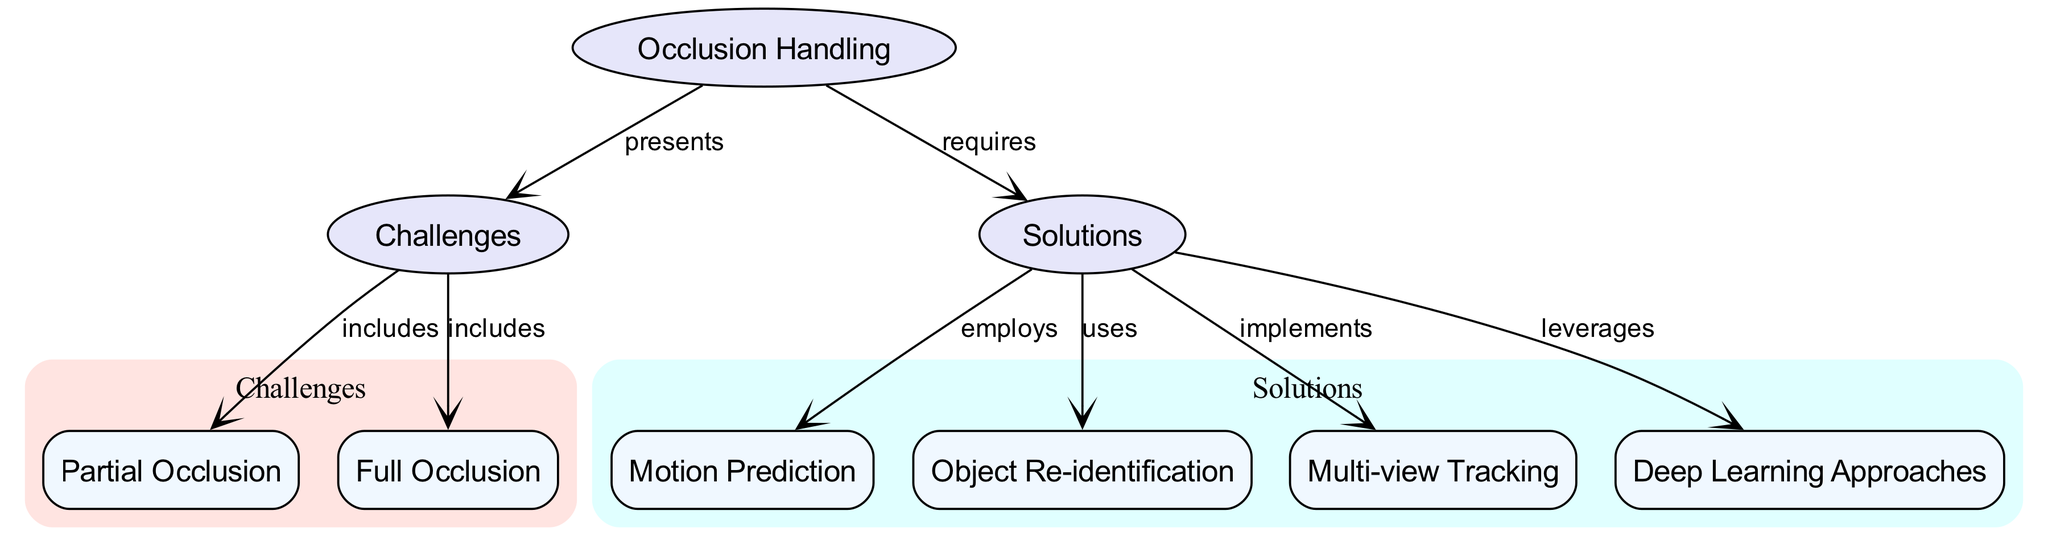What is the main topic of the concept map? The main topic is indicated by the central node "Occlusion Handling." It is the primary focus of the concept map as it serves as a parent node from which challenges and solutions branch out.
Answer: Occlusion Handling How many nodes are present in the concept map? By counting each unique entry in the nodes section of the data, we find there are eight nodes total connecting various concepts.
Answer: 8 What type of occlusion is included as a challenge in the diagram? The diagram indicates that both "Partial Occlusion" and "Full Occlusion" are included under the challenges node, showing two specific types recognized in motion tracking.
Answer: Partial Occlusion, Full Occlusion Which solution employs motion prediction? The diagram indicates that "Motion Prediction" is a solution that is employed under the solutions node, which is designed to address challenges related to occlusions.
Answer: Motion Prediction What connection is made between challenges and solutions? The diagram shows a clear relationship in that the node "Occlusion Handling" requires solutions to address the identified challenges, indicating a direct need for problem-solving approaches.
Answer: requires Which solution is associated with deep learning approaches? According to the diagram, there is a direct connection that states "Deep Learning Approaches" leverages one of the solutions provided to cope with challenges in occlusion handling.
Answer: Deep Learning Approaches How many specific solutions are listed in the diagram? The solutions node branches out into four distinct concepts, indicating multiple approaches to handle the challenges of occlusion, reflecting an array of solutions.
Answer: 4 Which type of tracking does the diagram indicate is implemented as a solution? The concept map highlights "Multi-view Tracking" specifically as one of the solutions used to enhance motion tracking's robustness against occlusions.
Answer: Multi-view Tracking What are the two types of challenges represented under challenges? The concept map lists the two types of occlusion challenges directly under the challenges node: "Partial Occlusion" and "Full Occlusion," making the distinction between them apparent.
Answer: Partial Occlusion, Full Occlusion 